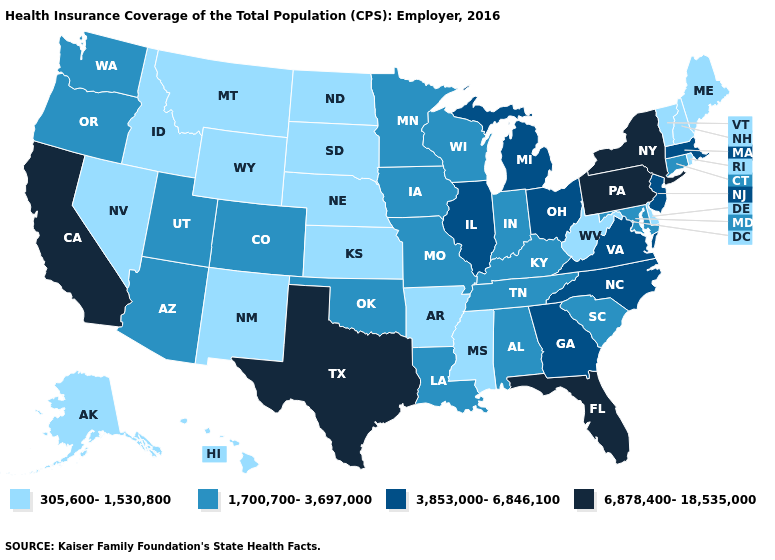Name the states that have a value in the range 305,600-1,530,800?
Concise answer only. Alaska, Arkansas, Delaware, Hawaii, Idaho, Kansas, Maine, Mississippi, Montana, Nebraska, Nevada, New Hampshire, New Mexico, North Dakota, Rhode Island, South Dakota, Vermont, West Virginia, Wyoming. Name the states that have a value in the range 6,878,400-18,535,000?
Give a very brief answer. California, Florida, New York, Pennsylvania, Texas. What is the highest value in the MidWest ?
Keep it brief. 3,853,000-6,846,100. Name the states that have a value in the range 305,600-1,530,800?
Be succinct. Alaska, Arkansas, Delaware, Hawaii, Idaho, Kansas, Maine, Mississippi, Montana, Nebraska, Nevada, New Hampshire, New Mexico, North Dakota, Rhode Island, South Dakota, Vermont, West Virginia, Wyoming. Is the legend a continuous bar?
Concise answer only. No. Name the states that have a value in the range 305,600-1,530,800?
Give a very brief answer. Alaska, Arkansas, Delaware, Hawaii, Idaho, Kansas, Maine, Mississippi, Montana, Nebraska, Nevada, New Hampshire, New Mexico, North Dakota, Rhode Island, South Dakota, Vermont, West Virginia, Wyoming. Name the states that have a value in the range 1,700,700-3,697,000?
Write a very short answer. Alabama, Arizona, Colorado, Connecticut, Indiana, Iowa, Kentucky, Louisiana, Maryland, Minnesota, Missouri, Oklahoma, Oregon, South Carolina, Tennessee, Utah, Washington, Wisconsin. Name the states that have a value in the range 3,853,000-6,846,100?
Give a very brief answer. Georgia, Illinois, Massachusetts, Michigan, New Jersey, North Carolina, Ohio, Virginia. What is the value of Utah?
Answer briefly. 1,700,700-3,697,000. What is the value of Arkansas?
Give a very brief answer. 305,600-1,530,800. What is the value of Hawaii?
Give a very brief answer. 305,600-1,530,800. Which states hav the highest value in the MidWest?
Answer briefly. Illinois, Michigan, Ohio. Does Texas have the highest value in the USA?
Give a very brief answer. Yes. What is the value of Pennsylvania?
Short answer required. 6,878,400-18,535,000. Among the states that border Pennsylvania , does West Virginia have the lowest value?
Write a very short answer. Yes. 